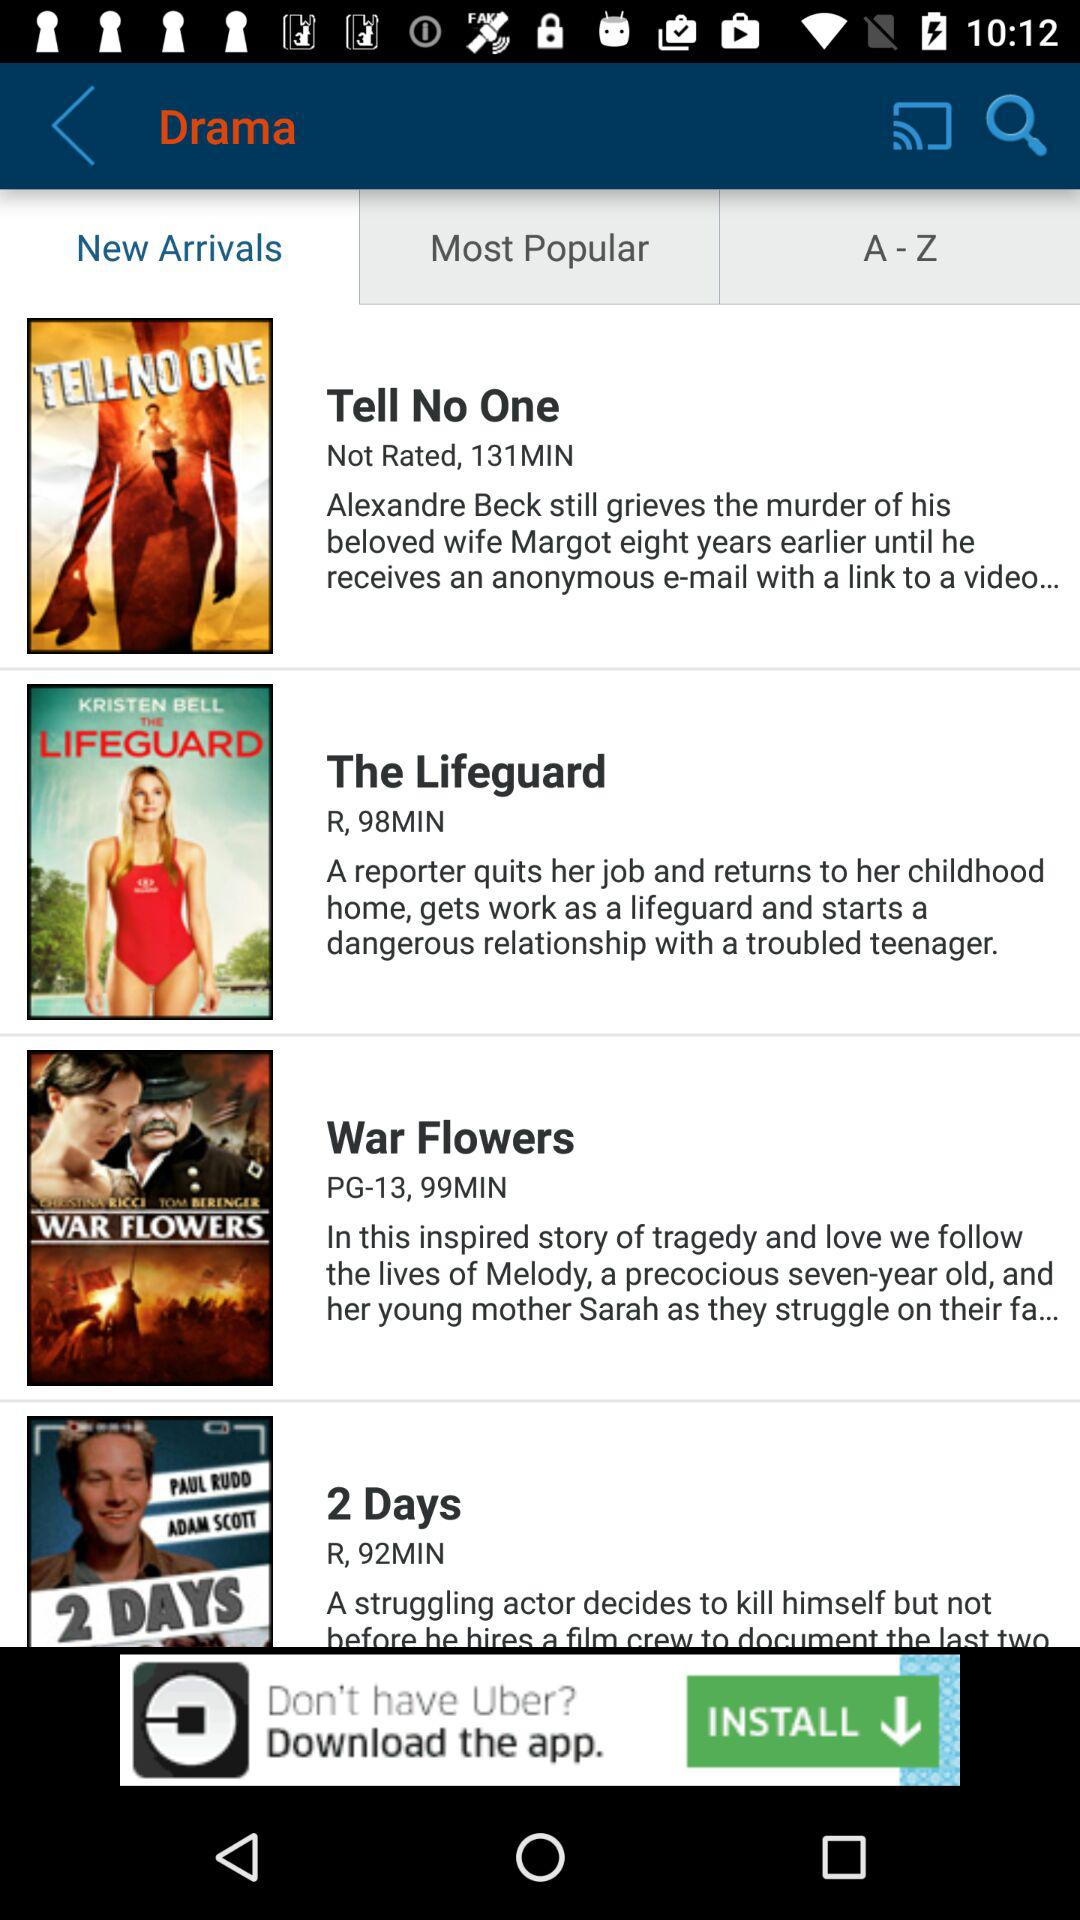What is the duration of the drama War Flowers? The duration is 99 minutes. 